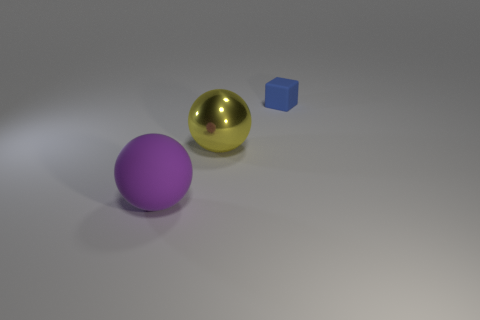Is there anything else that is made of the same material as the yellow sphere?
Provide a succinct answer. No. How many shiny objects are either red cubes or small blue cubes?
Ensure brevity in your answer.  0. What number of tiny rubber objects are the same color as the block?
Provide a succinct answer. 0. The large sphere that is behind the matte thing that is in front of the blue block is made of what material?
Your response must be concise. Metal. How big is the rubber block?
Offer a terse response. Small. How many purple rubber spheres are the same size as the yellow metal object?
Keep it short and to the point. 1. What number of large red objects have the same shape as the yellow thing?
Give a very brief answer. 0. Are there an equal number of purple things that are in front of the purple ball and big brown matte spheres?
Provide a succinct answer. Yes. Is there anything else that has the same size as the purple matte thing?
Give a very brief answer. Yes. What is the shape of the yellow metallic thing that is the same size as the purple rubber ball?
Offer a terse response. Sphere. 